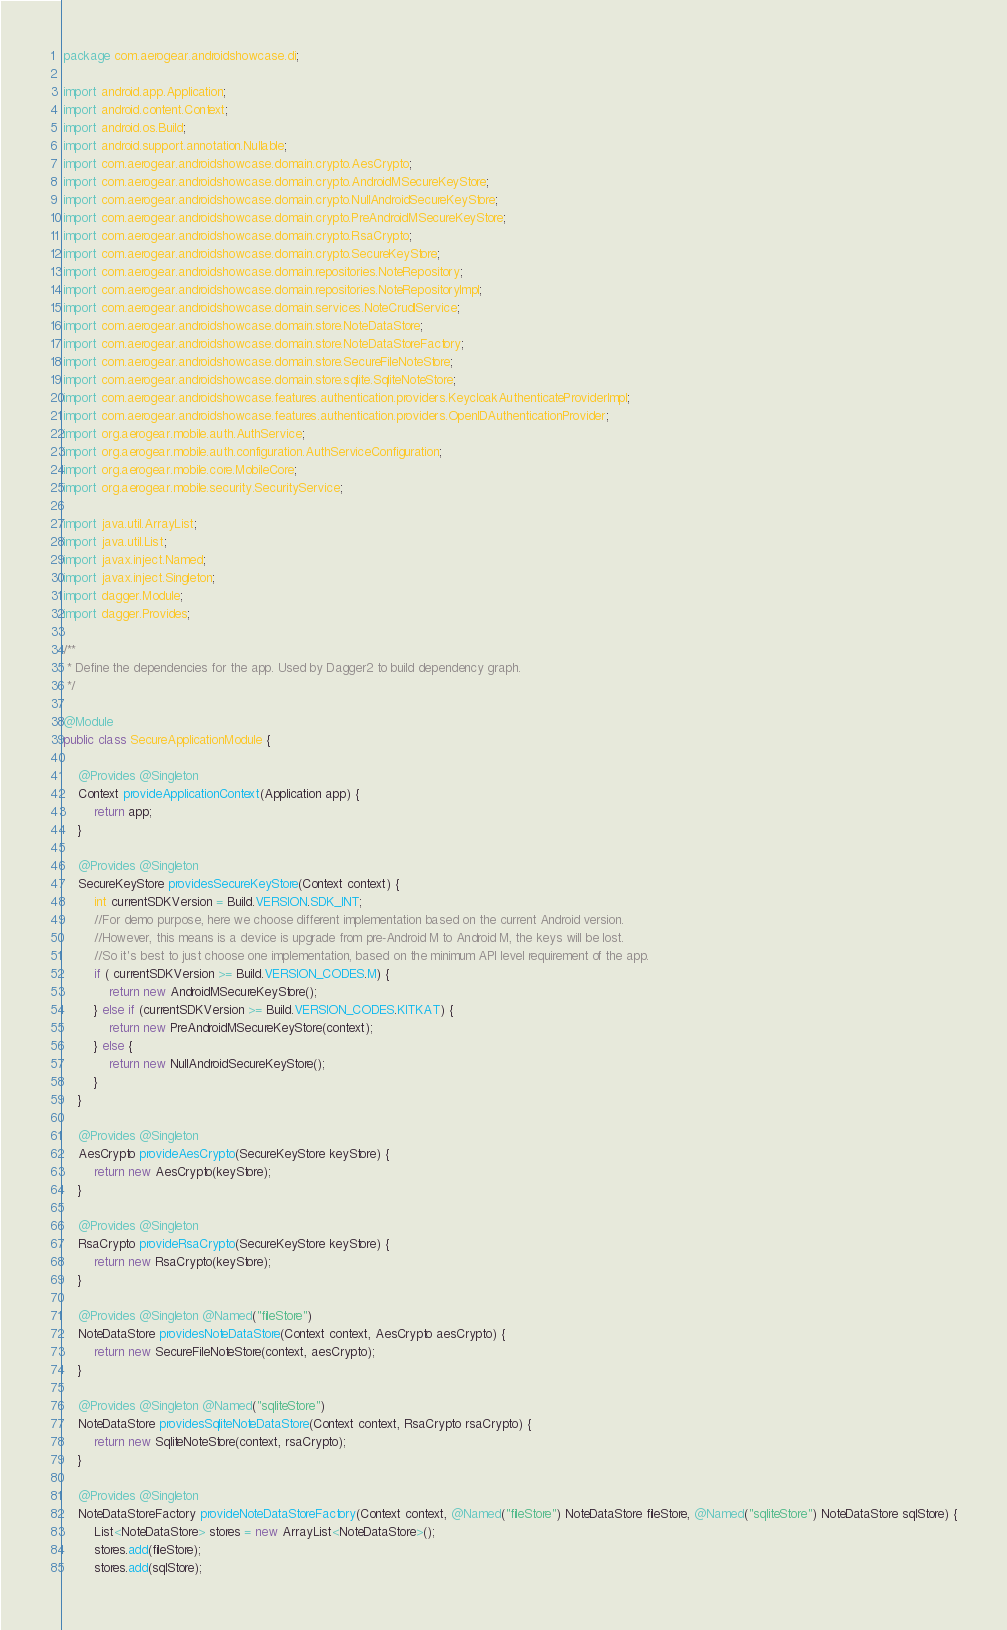<code> <loc_0><loc_0><loc_500><loc_500><_Java_>package com.aerogear.androidshowcase.di;

import android.app.Application;
import android.content.Context;
import android.os.Build;
import android.support.annotation.Nullable;
import com.aerogear.androidshowcase.domain.crypto.AesCrypto;
import com.aerogear.androidshowcase.domain.crypto.AndroidMSecureKeyStore;
import com.aerogear.androidshowcase.domain.crypto.NullAndroidSecureKeyStore;
import com.aerogear.androidshowcase.domain.crypto.PreAndroidMSecureKeyStore;
import com.aerogear.androidshowcase.domain.crypto.RsaCrypto;
import com.aerogear.androidshowcase.domain.crypto.SecureKeyStore;
import com.aerogear.androidshowcase.domain.repositories.NoteRepository;
import com.aerogear.androidshowcase.domain.repositories.NoteRepositoryImpl;
import com.aerogear.androidshowcase.domain.services.NoteCrudlService;
import com.aerogear.androidshowcase.domain.store.NoteDataStore;
import com.aerogear.androidshowcase.domain.store.NoteDataStoreFactory;
import com.aerogear.androidshowcase.domain.store.SecureFileNoteStore;
import com.aerogear.androidshowcase.domain.store.sqlite.SqliteNoteStore;
import com.aerogear.androidshowcase.features.authentication.providers.KeycloakAuthenticateProviderImpl;
import com.aerogear.androidshowcase.features.authentication.providers.OpenIDAuthenticationProvider;
import org.aerogear.mobile.auth.AuthService;
import org.aerogear.mobile.auth.configuration.AuthServiceConfiguration;
import org.aerogear.mobile.core.MobileCore;
import org.aerogear.mobile.security.SecurityService;

import java.util.ArrayList;
import java.util.List;
import javax.inject.Named;
import javax.inject.Singleton;
import dagger.Module;
import dagger.Provides;

/**
 * Define the dependencies for the app. Used by Dagger2 to build dependency graph.
 */

@Module
public class SecureApplicationModule {

    @Provides @Singleton
    Context provideApplicationContext(Application app) {
        return app;
    }

    @Provides @Singleton
    SecureKeyStore providesSecureKeyStore(Context context) {
        int currentSDKVersion = Build.VERSION.SDK_INT;
        //For demo purpose, here we choose different implementation based on the current Android version.
        //However, this means is a device is upgrade from pre-Android M to Android M, the keys will be lost.
        //So it's best to just choose one implementation, based on the minimum API level requirement of the app.
        if ( currentSDKVersion >= Build.VERSION_CODES.M) {
            return new AndroidMSecureKeyStore();
        } else if (currentSDKVersion >= Build.VERSION_CODES.KITKAT) {
            return new PreAndroidMSecureKeyStore(context);
        } else {
            return new NullAndroidSecureKeyStore();
        }
    }

    @Provides @Singleton
    AesCrypto provideAesCrypto(SecureKeyStore keyStore) {
        return new AesCrypto(keyStore);
    }

    @Provides @Singleton
    RsaCrypto provideRsaCrypto(SecureKeyStore keyStore) {
        return new RsaCrypto(keyStore);
    }

    @Provides @Singleton @Named("fileStore")
    NoteDataStore providesNoteDataStore(Context context, AesCrypto aesCrypto) {
        return new SecureFileNoteStore(context, aesCrypto);
    }

    @Provides @Singleton @Named("sqliteStore")
    NoteDataStore providesSqliteNoteDataStore(Context context, RsaCrypto rsaCrypto) {
        return new SqliteNoteStore(context, rsaCrypto);
    }

    @Provides @Singleton
    NoteDataStoreFactory provideNoteDataStoreFactory(Context context, @Named("fileStore") NoteDataStore fileStore, @Named("sqliteStore") NoteDataStore sqlStore) {
        List<NoteDataStore> stores = new ArrayList<NoteDataStore>();
        stores.add(fileStore);
        stores.add(sqlStore);</code> 